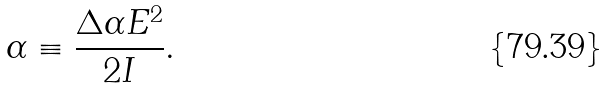<formula> <loc_0><loc_0><loc_500><loc_500>\alpha \equiv \frac { \Delta \alpha E ^ { 2 } } { 2 I } .</formula> 